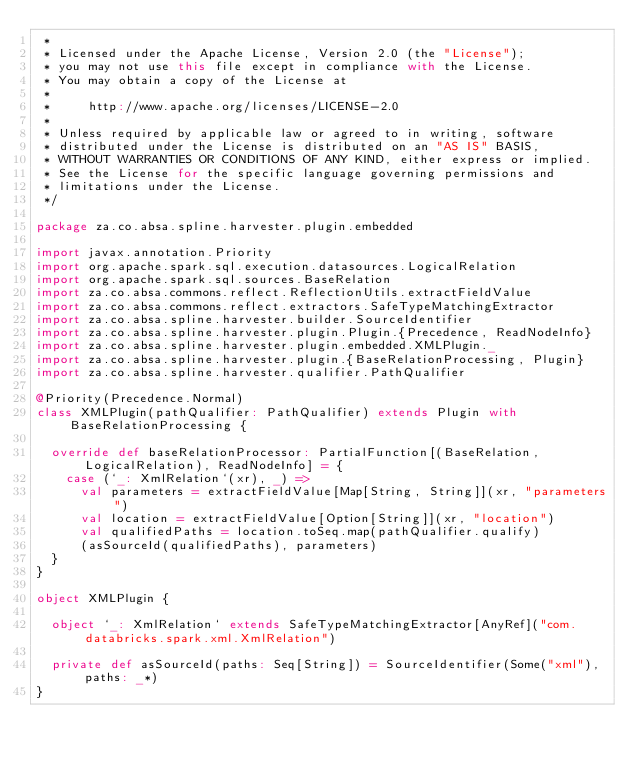Convert code to text. <code><loc_0><loc_0><loc_500><loc_500><_Scala_> *
 * Licensed under the Apache License, Version 2.0 (the "License");
 * you may not use this file except in compliance with the License.
 * You may obtain a copy of the License at
 *
 *     http://www.apache.org/licenses/LICENSE-2.0
 *
 * Unless required by applicable law or agreed to in writing, software
 * distributed under the License is distributed on an "AS IS" BASIS,
 * WITHOUT WARRANTIES OR CONDITIONS OF ANY KIND, either express or implied.
 * See the License for the specific language governing permissions and
 * limitations under the License.
 */

package za.co.absa.spline.harvester.plugin.embedded

import javax.annotation.Priority
import org.apache.spark.sql.execution.datasources.LogicalRelation
import org.apache.spark.sql.sources.BaseRelation
import za.co.absa.commons.reflect.ReflectionUtils.extractFieldValue
import za.co.absa.commons.reflect.extractors.SafeTypeMatchingExtractor
import za.co.absa.spline.harvester.builder.SourceIdentifier
import za.co.absa.spline.harvester.plugin.Plugin.{Precedence, ReadNodeInfo}
import za.co.absa.spline.harvester.plugin.embedded.XMLPlugin._
import za.co.absa.spline.harvester.plugin.{BaseRelationProcessing, Plugin}
import za.co.absa.spline.harvester.qualifier.PathQualifier

@Priority(Precedence.Normal)
class XMLPlugin(pathQualifier: PathQualifier) extends Plugin with BaseRelationProcessing {

  override def baseRelationProcessor: PartialFunction[(BaseRelation, LogicalRelation), ReadNodeInfo] = {
    case (`_: XmlRelation`(xr), _) =>
      val parameters = extractFieldValue[Map[String, String]](xr, "parameters")
      val location = extractFieldValue[Option[String]](xr, "location")
      val qualifiedPaths = location.toSeq.map(pathQualifier.qualify)
      (asSourceId(qualifiedPaths), parameters)
  }
}

object XMLPlugin {

  object `_: XmlRelation` extends SafeTypeMatchingExtractor[AnyRef]("com.databricks.spark.xml.XmlRelation")

  private def asSourceId(paths: Seq[String]) = SourceIdentifier(Some("xml"), paths: _*)
}
</code> 